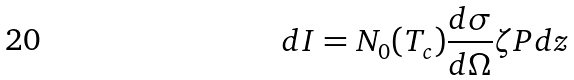<formula> <loc_0><loc_0><loc_500><loc_500>d I = N _ { 0 } ( T _ { c } ) \frac { d \sigma } { d \Omega } \zeta P d z</formula> 